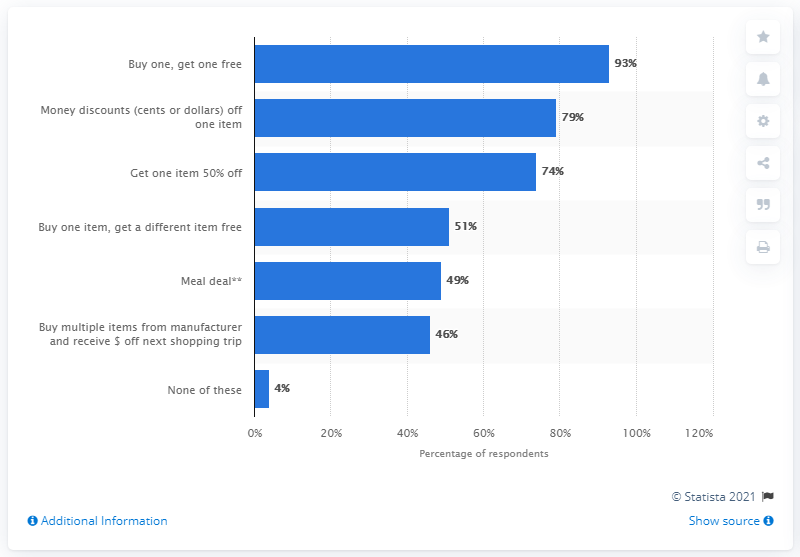Indicate a few pertinent items in this graphic. According to the responses of 74% of the respondents, the most common promotional offer they had taken advantage of was to get one item 50% off. 